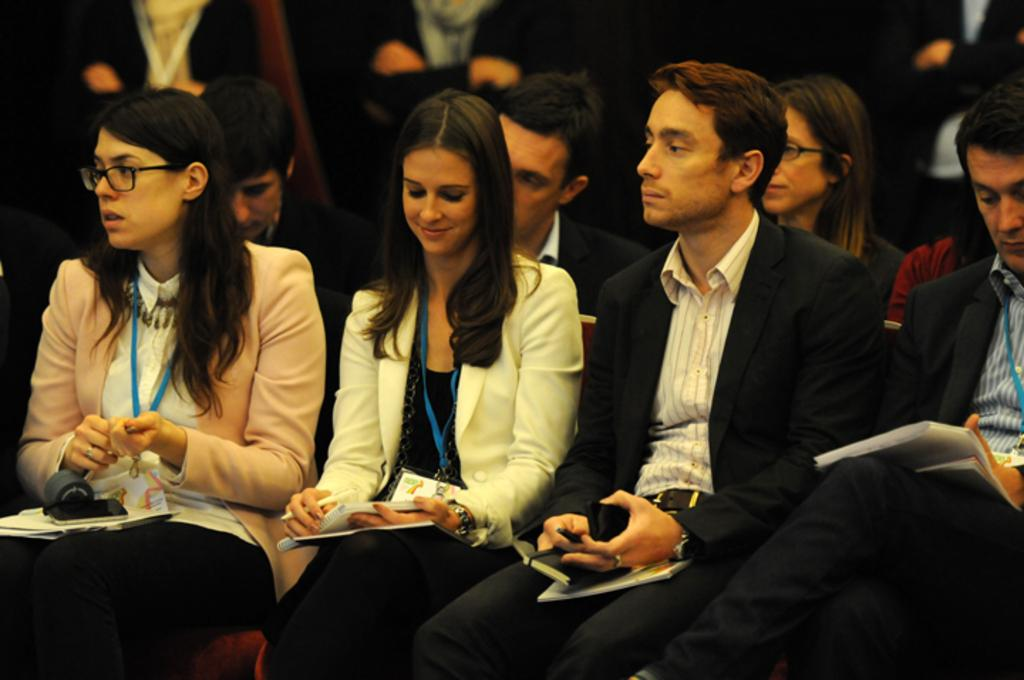What is happening in the image? There are people in the image, and some of them are holding things. Can you describe the position of the people holding things? The people holding things are sitting on chairs. Are there any other people visible in the image? Yes, there are other people visible in the background of the image. What type of quince can be seen in the image? There is no quince present in the image. What border is visible around the people in the image? There is no border visible around the people in the image. 